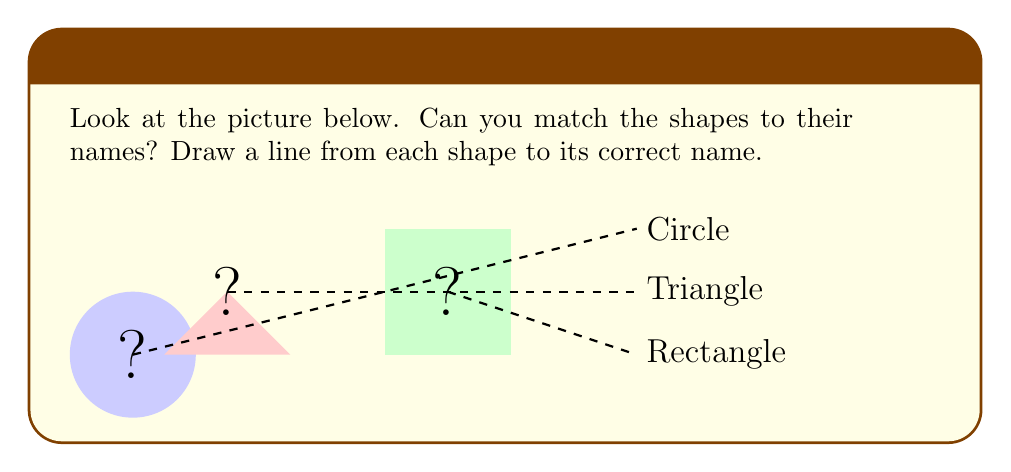What is the answer to this math problem? Let's look at each shape and match it to its name:

1. The first shape is round and has no corners. It looks like a ball. This shape is called a circle.

2. The second shape has three sides and three corners. It looks like a pizza slice. This shape is called a triangle.

3. The third shape has four sides and four corners. It looks like a door or a window. This shape is called a rectangle.

To answer this question, we need to draw lines connecting each shape to its correct name. The lines are already drawn for us in the picture.

Remember:
- Round shape with no corners = Circle
- Three sides and three corners = Triangle
- Four sides and four corners = Rectangle

By matching these descriptions to the shapes in the picture, we can see that the lines are correctly drawn to match each shape with its name.
Answer: The correct matches are:
- Round shape (left) to Circle
- Three-sided shape (middle) to Triangle
- Four-sided shape (right) to Rectangle 